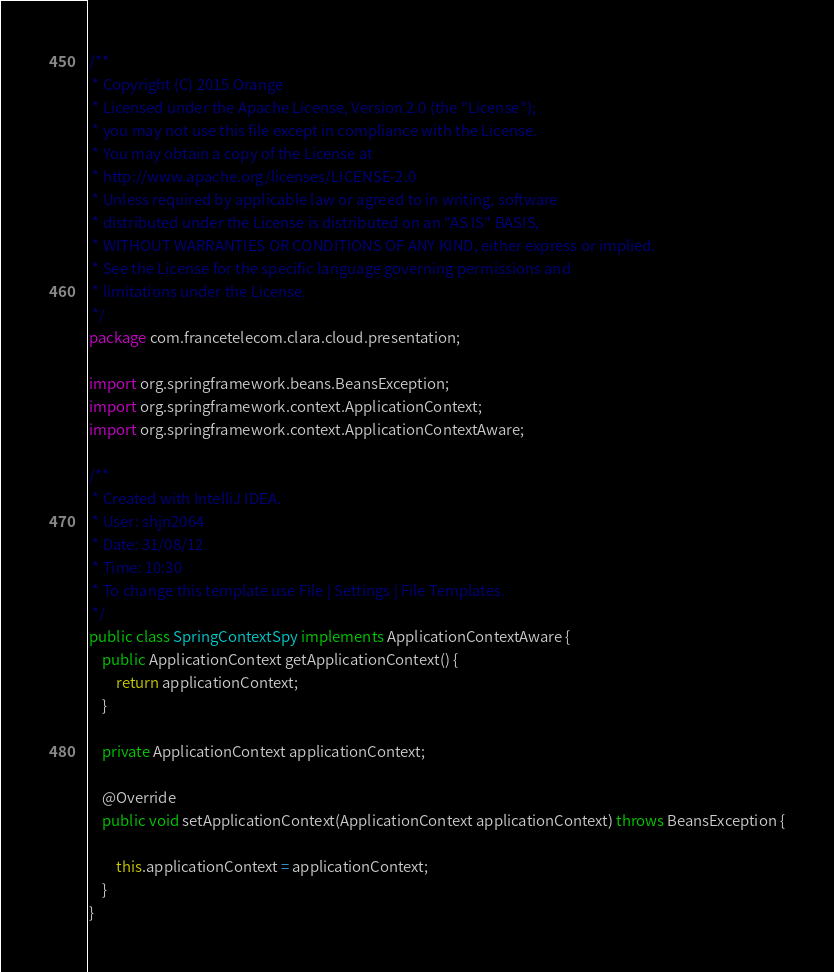Convert code to text. <code><loc_0><loc_0><loc_500><loc_500><_Java_>/**
 * Copyright (C) 2015 Orange
 * Licensed under the Apache License, Version 2.0 (the "License");
 * you may not use this file except in compliance with the License.
 * You may obtain a copy of the License at
 * http://www.apache.org/licenses/LICENSE-2.0
 * Unless required by applicable law or agreed to in writing, software
 * distributed under the License is distributed on an "AS IS" BASIS,
 * WITHOUT WARRANTIES OR CONDITIONS OF ANY KIND, either express or implied.
 * See the License for the specific language governing permissions and
 * limitations under the License.
 */
package com.francetelecom.clara.cloud.presentation;

import org.springframework.beans.BeansException;
import org.springframework.context.ApplicationContext;
import org.springframework.context.ApplicationContextAware;

/**
 * Created with IntelliJ IDEA.
 * User: shjn2064
 * Date: 31/08/12
 * Time: 10:30
 * To change this template use File | Settings | File Templates.
 */
public class SpringContextSpy implements ApplicationContextAware {
    public ApplicationContext getApplicationContext() {
        return applicationContext;
    }

    private ApplicationContext applicationContext;

    @Override
    public void setApplicationContext(ApplicationContext applicationContext) throws BeansException {

        this.applicationContext = applicationContext;
    }
}
</code> 